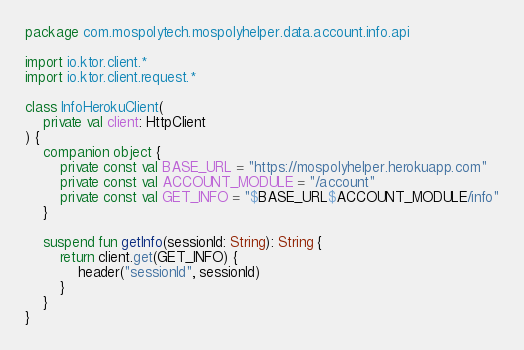<code> <loc_0><loc_0><loc_500><loc_500><_Kotlin_>package com.mospolytech.mospolyhelper.data.account.info.api

import io.ktor.client.*
import io.ktor.client.request.*

class InfoHerokuClient(
    private val client: HttpClient
) {
    companion object {
        private const val BASE_URL = "https://mospolyhelper.herokuapp.com"
        private const val ACCOUNT_MODULE = "/account"
        private const val GET_INFO = "$BASE_URL$ACCOUNT_MODULE/info"
    }

    suspend fun getInfo(sessionId: String): String {
        return client.get(GET_INFO) {
            header("sessionId", sessionId)
        }
    }
}</code> 